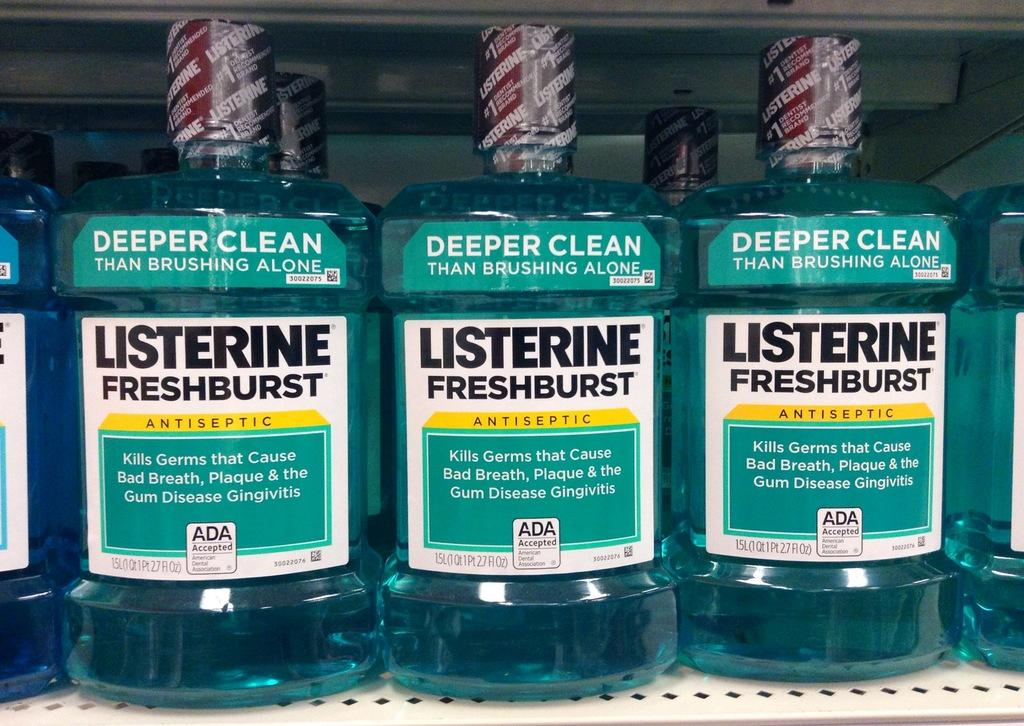<image>
Relay a brief, clear account of the picture shown. lots of bottles of brand new listerine fresh burts sit on the shelf 